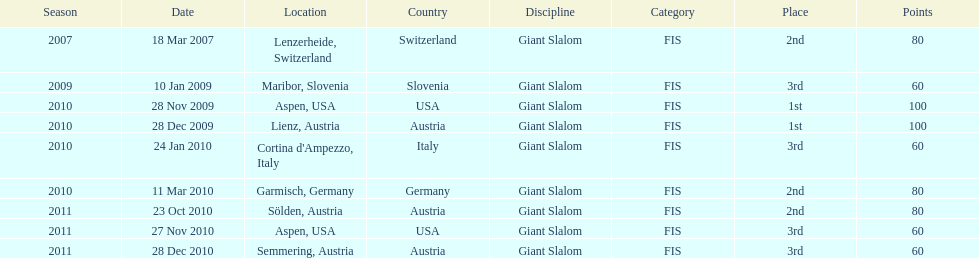How many races were in 2010? 5. 